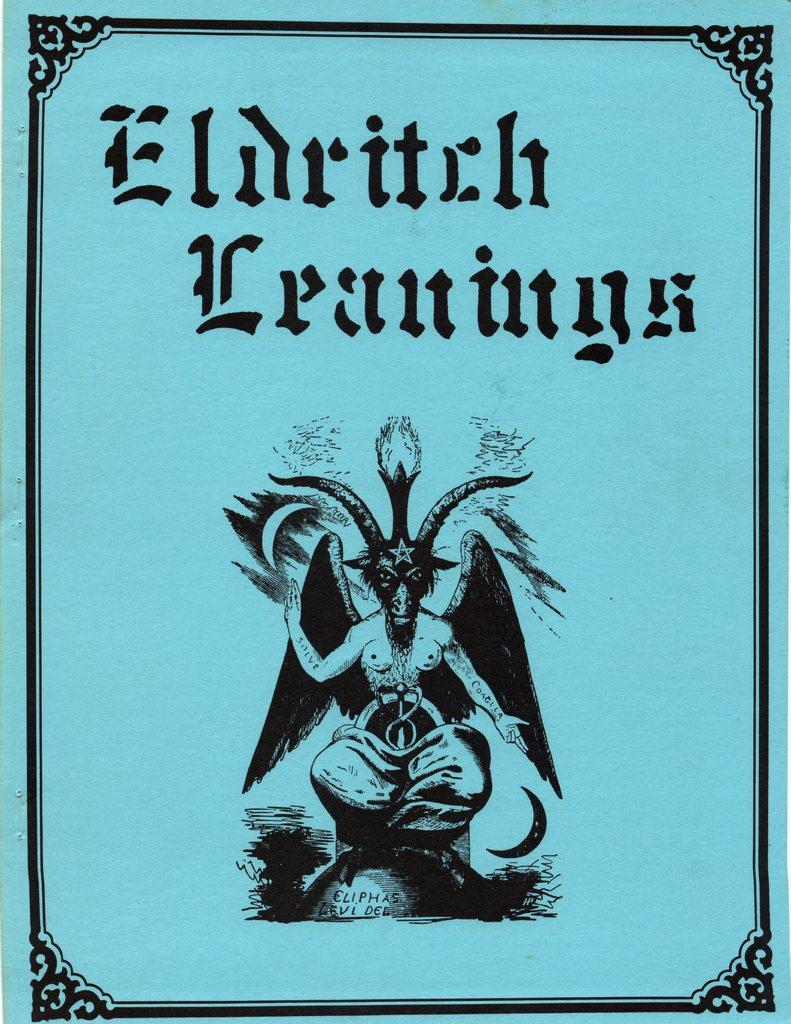<image>
Relay a brief, clear account of the picture shown. the cover of the book eldritch leanings with a picture of a demon on the bottom. 